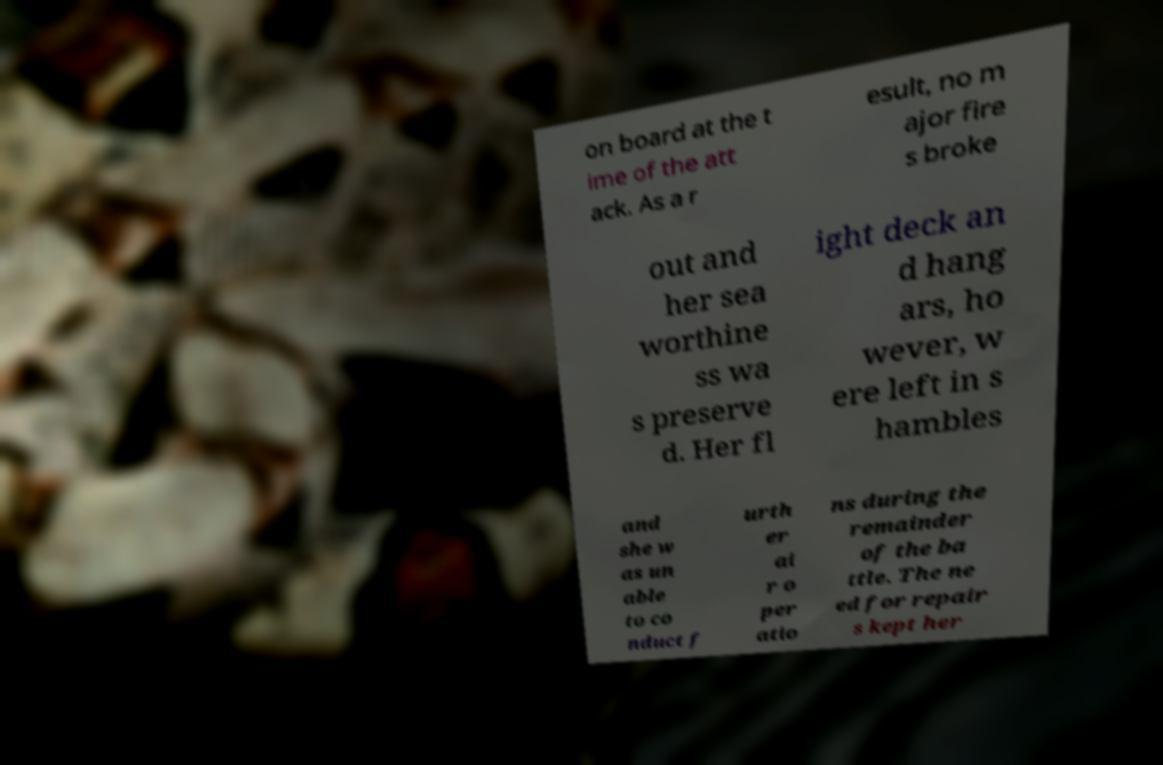Can you accurately transcribe the text from the provided image for me? on board at the t ime of the att ack. As a r esult, no m ajor fire s broke out and her sea worthine ss wa s preserve d. Her fl ight deck an d hang ars, ho wever, w ere left in s hambles and she w as un able to co nduct f urth er ai r o per atio ns during the remainder of the ba ttle. The ne ed for repair s kept her 